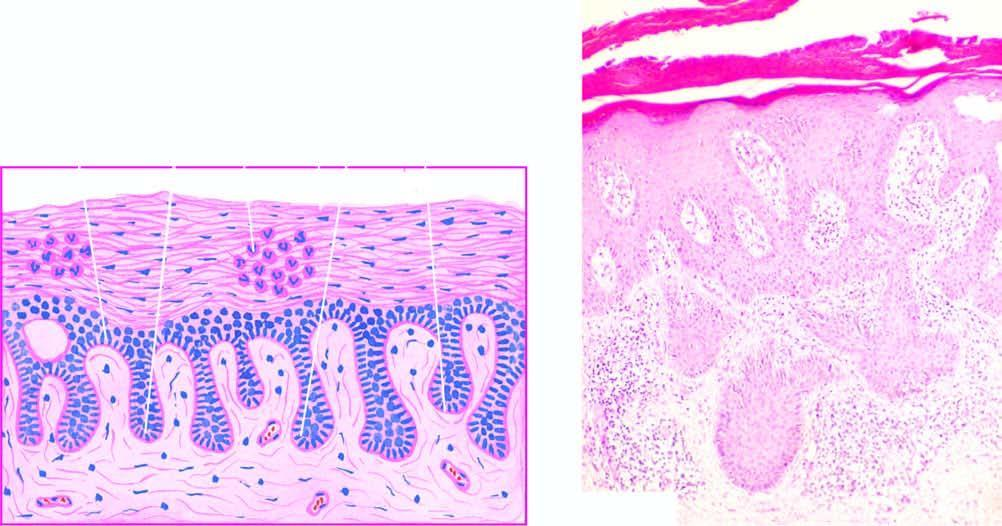there is regular elongation of the rete ridges with thickening of whose lower portion?
Answer the question using a single word or phrase. Their 